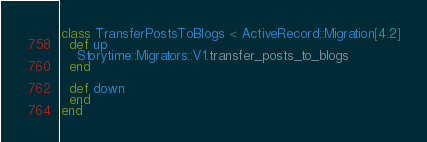Convert code to text. <code><loc_0><loc_0><loc_500><loc_500><_Ruby_>class TransferPostsToBlogs < ActiveRecord::Migration[4.2]
  def up
    Storytime::Migrators::V1.transfer_posts_to_blogs
  end

  def down
  end
end
</code> 